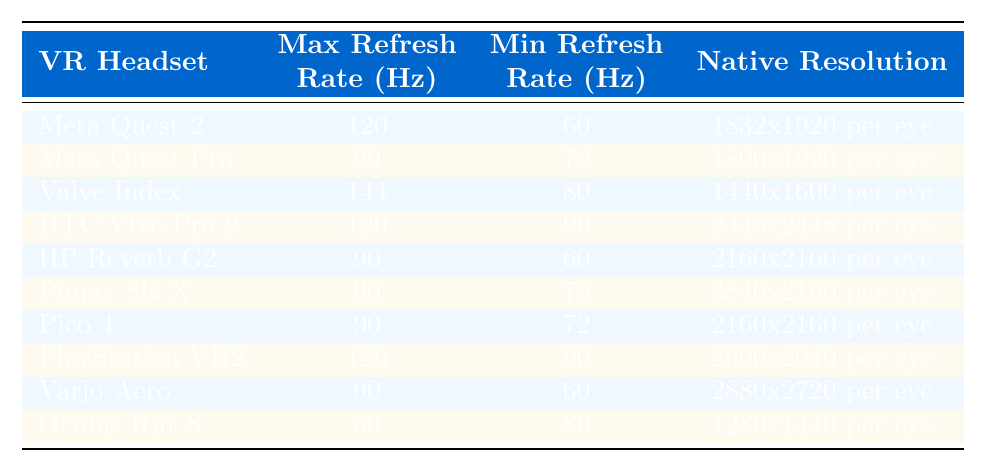What is the maximum refresh rate of the Valve Index? The table shows that the maximum refresh rate for the Valve Index is 144 Hz.
Answer: 144 Hz Which VR headset has the highest minimum refresh rate? By checking the table, it is evident that the HTC Vive Pro 2 has the highest minimum refresh rate at 90 Hz.
Answer: HTC Vive Pro 2 Does the Meta Quest Pro have a native resolution higher than the HP Reverb G2? The native resolution for Meta Quest Pro is 1800x1920 and for HP Reverb G2 is 2160x2160. Since 2160x2160 is higher, the statement is false.
Answer: No How many VR headsets have a maximum refresh rate of 90 Hz? From the table, the headsets with a maximum refresh rate of 90 Hz are Meta Quest Pro, HP Reverb G2, Pimax 8K X, Pico 4, and Varjo Aero, which totals to 5.
Answer: 5 What is the average maximum refresh rate of all listed VR headsets? The maximum refresh rates are 120, 90, 144, 120, 90, 90, 90, 120, 90, and 80. Adding these gives 1,042, and dividing by 10 gives an average of 104.2.
Answer: 104.2 Is there any VR headset that features a maximum refresh rate less than 90 Hz? According to the table, the Oculus Rift S has a maximum refresh rate of 80 Hz, confirming that at least one headset falls below this rate.
Answer: Yes What is the difference between the maximum refresh rates of the HTC Vive Pro 2 and the Valve Index? The maximum refresh rate of HTC Vive Pro 2 is 120 Hz and for Valve Index is 144 Hz. The difference is 144 - 120 = 24 Hz.
Answer: 24 Hz Which headset has the highest native resolution and what is that resolution? Checking the table, the Pimax 8K X has the highest native resolution of 3840x2160 per eye.
Answer: 3840x2160 per eye How many headsets have a maximum refresh rate of 120 Hz? The table indicates that there are three headsets: Meta Quest 2, HTC Vive Pro 2, and PlayStation VR2 that have a maximum refresh rate of 120 Hz.
Answer: 3 Is the HP Reverb G2's maximum refresh rate equal to its minimum refresh rate? The maximum refresh rate of HP Reverb G2 is 90 Hz and its minimum is 60 Hz, thus they are not equal, making the statement false.
Answer: No 